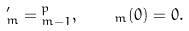Convert formula to latex. <formula><loc_0><loc_0><loc_500><loc_500>\L _ { m } ^ { \prime } = \L \L _ { m - 1 } ^ { p } , \quad \L _ { m } ( 0 ) = 0 .</formula> 